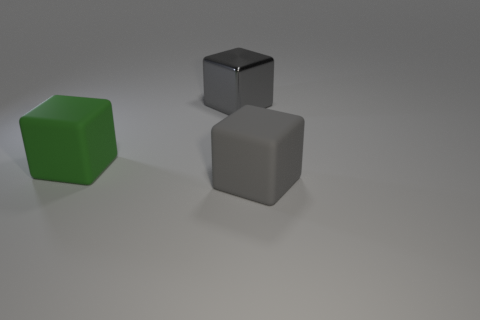What is the size of the block that is the same color as the large metallic thing?
Your answer should be very brief. Large. Does the gray rubber object have the same size as the shiny block?
Provide a succinct answer. Yes. What number of objects are big green things or large cubes right of the gray metal object?
Your answer should be compact. 2. What number of things are objects in front of the large metal object or large blocks behind the gray rubber object?
Make the answer very short. 3. There is a big gray shiny block; are there any metallic objects right of it?
Ensure brevity in your answer.  No. There is a big object to the right of the gray block that is to the left of the matte thing in front of the green rubber cube; what is its color?
Provide a short and direct response. Gray. Is the big green matte thing the same shape as the gray rubber thing?
Give a very brief answer. Yes. There is a large block that is the same material as the big green object; what color is it?
Your response must be concise. Gray. What number of things are large things to the right of the large metal thing or gray metal cubes?
Your response must be concise. 2. There is a gray thing in front of the green matte block; what size is it?
Give a very brief answer. Large. 